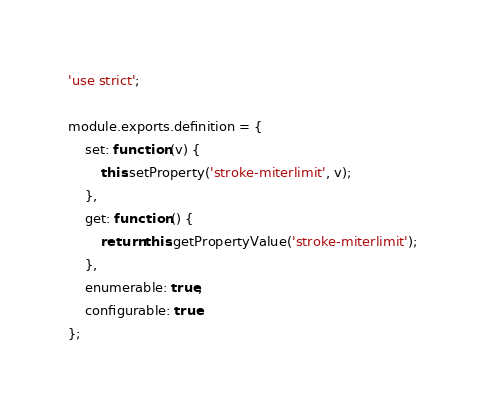<code> <loc_0><loc_0><loc_500><loc_500><_JavaScript_>'use strict';

module.exports.definition = {
    set: function (v) {
        this.setProperty('stroke-miterlimit', v);
    },
    get: function () {
        return this.getPropertyValue('stroke-miterlimit');
    },
    enumerable: true,
    configurable: true
};
</code> 